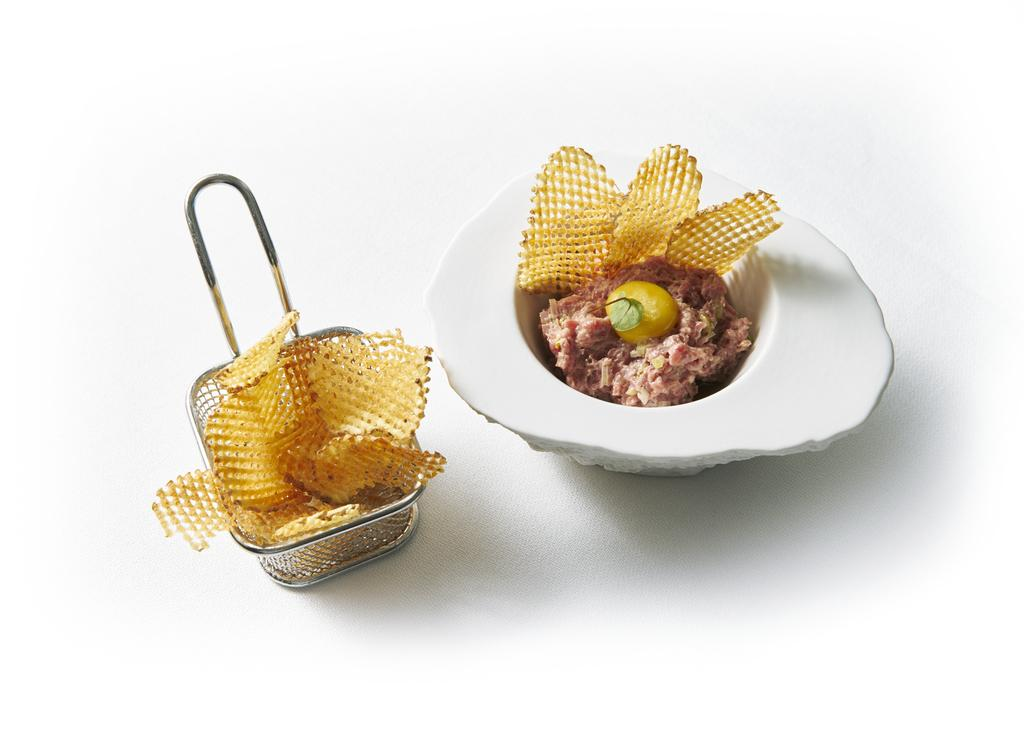What is located on the left side of the image? There is a chip pan on the left side of the image. What is inside the chip pan? The chip pan contains chips. What other object is present beside the chip pan? There is a stone pounder beside the chip pan. What is inside the stone pounder? The stone pounder contains meat and chips. What is the color of the surface on which the objects are placed? The objects are placed on a white surface. How many flights are visible in the image? There are no flights visible in the image; it features a chip pan, a stone pounder, and a white surface. What type of sponge is used to clean the stone pounder in the image? There is no sponge present in the image, and therefore no such cleaning activity can be observed. 